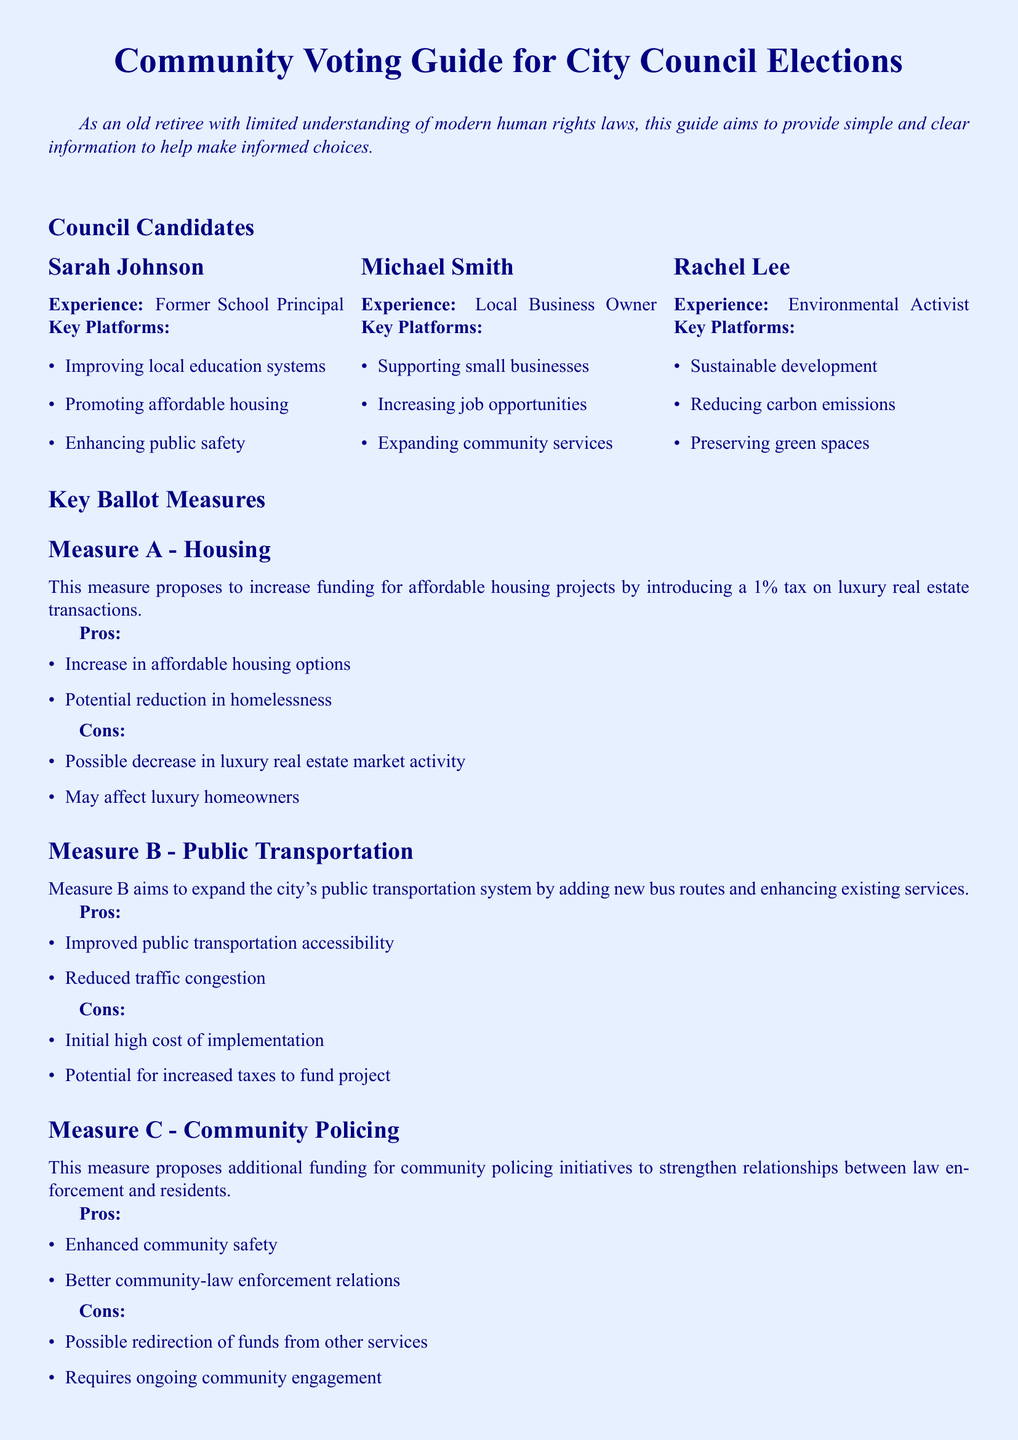What is Sarah Johnson's experience? Sarah Johnson is a Former School Principal, which is stated in her candidate profile in the document.
Answer: Former School Principal What platform does Michael Smith support? One of the key platforms of Michael Smith mentioned in the document is increasing job opportunities.
Answer: Increasing job opportunities What is the tax rate proposed in Measure A? Measure A proposes to introduce a 1% tax on luxury real estate transactions as indicated in the document.
Answer: 1% What are the pros of Measure B? The document lists improved public transportation accessibility and reduced traffic congestion as pros of Measure B.
Answer: Improved public transportation accessibility, Reduced traffic congestion What is one con of Measure C? One of the cons of Measure C mentioned in the document is the possible redirection of funds from other services.
Answer: Possible redirection of funds from other services Who is an environmental activist candidate? Rachel Lee is identified as an Environmental Activist in her candidate profile in the document.
Answer: Rachel Lee What does Measure A aim to address? Measure A aims to address affordable housing projects, as stated in the document.
Answer: Affordable housing projects What kind of experience does Michael Smith have? Michael Smith has experience as a Local Business Owner which is mentioned in the document.
Answer: Local Business Owner What is the main goal of Measure B? The main goal of Measure B is to expand the city's public transportation system as explained in the document.
Answer: Expand public transportation system 